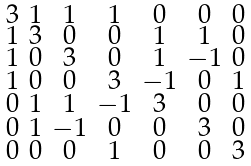Convert formula to latex. <formula><loc_0><loc_0><loc_500><loc_500>\begin{smallmatrix} 3 & 1 & 1 & 1 & 0 & 0 & 0 \\ 1 & 3 & 0 & 0 & 1 & 1 & 0 \\ 1 & 0 & 3 & 0 & 1 & - 1 & 0 \\ 1 & 0 & 0 & 3 & - 1 & 0 & 1 \\ 0 & 1 & 1 & - 1 & 3 & 0 & 0 \\ 0 & 1 & - 1 & 0 & 0 & 3 & 0 \\ 0 & 0 & 0 & 1 & 0 & 0 & 3 \end{smallmatrix}</formula> 